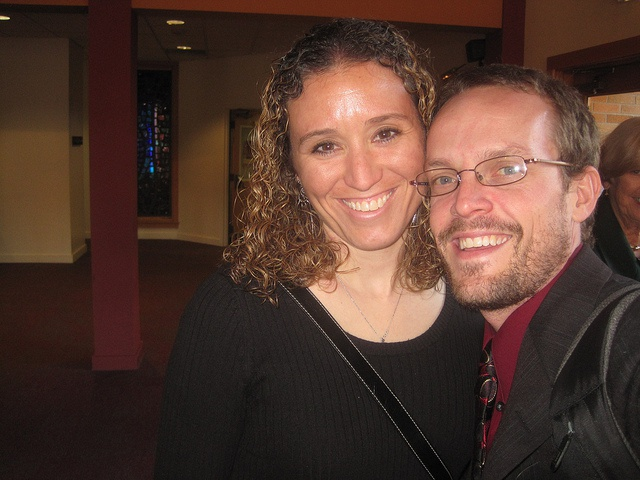Describe the objects in this image and their specific colors. I can see people in maroon, black, tan, and salmon tones, people in maroon, black, salmon, and brown tones, people in maroon, black, and brown tones, handbag in maroon, black, gray, and darkgray tones, and tie in maroon, black, and brown tones in this image. 